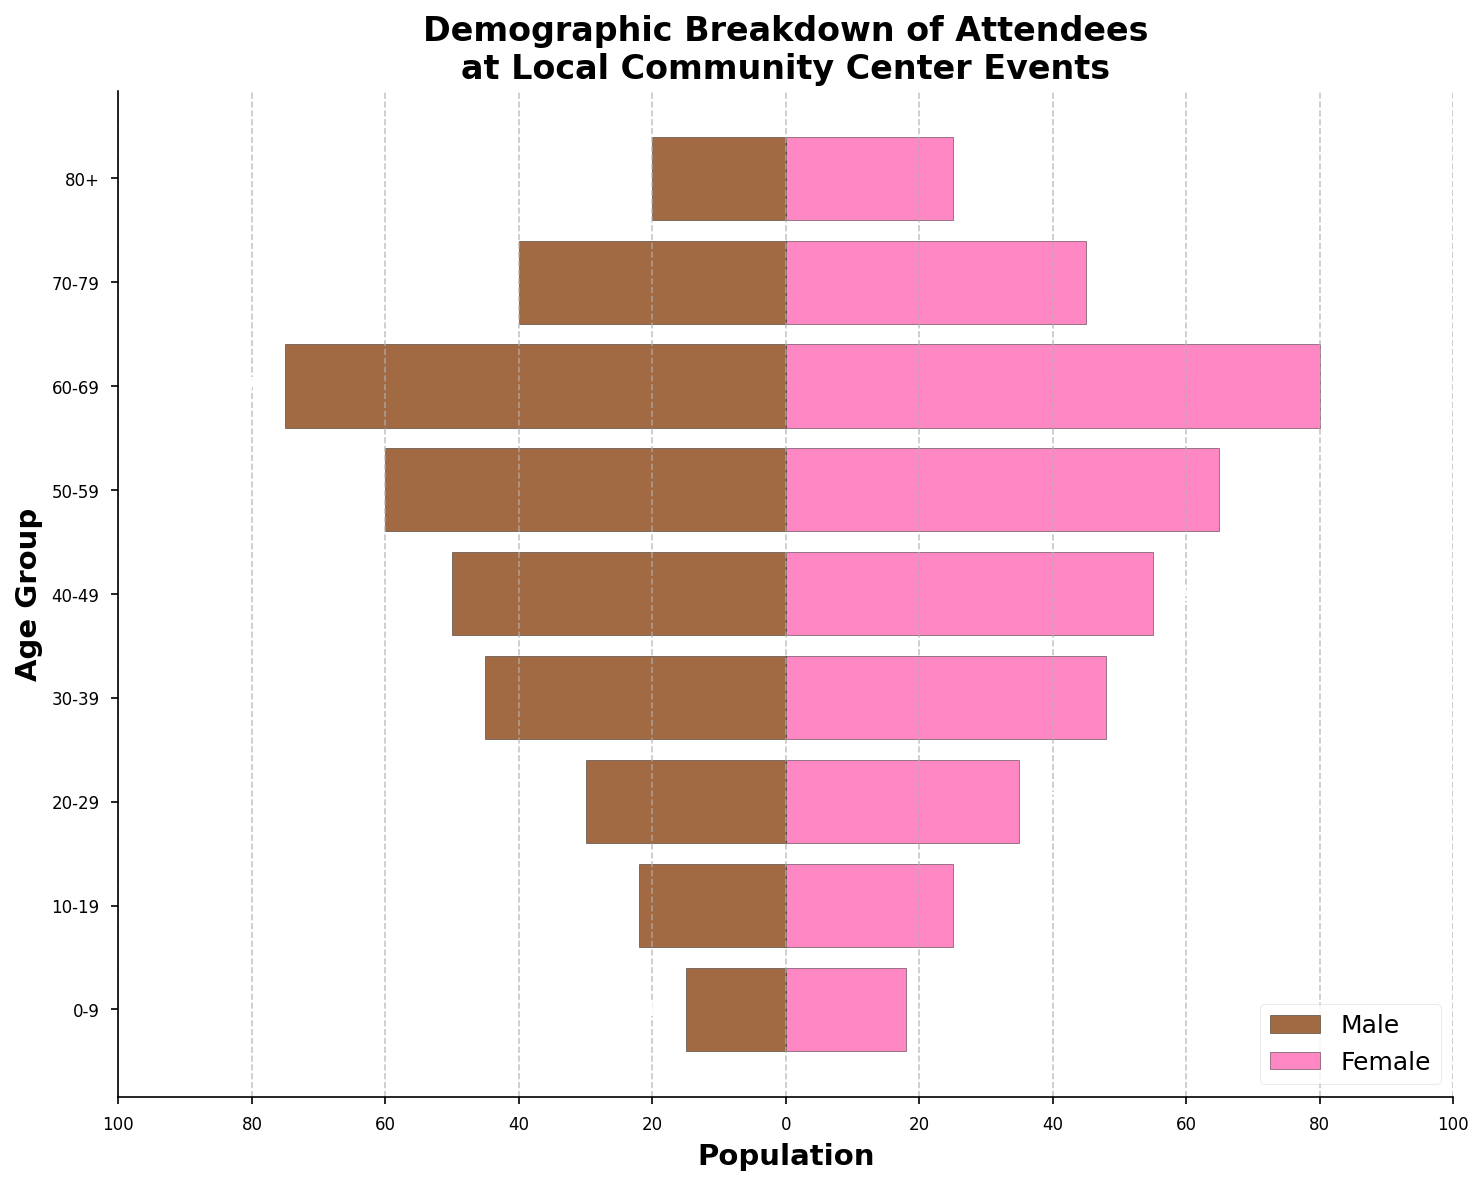Which age group has the highest number of male attendees? The age group with the most male attendees is indicated by the largest bar extending to the left. The 60-69 age group has a bar extending furthest to the left in the male section, indicating the highest number of male attendees.
Answer: 60-69 Which age group has the fewest female attendees? The age group with the fewest female attendees is indicated by the shortest bar extending to the right. The 80+ age group has the shortest bar in the female section, indicating the fewest female attendees.
Answer: 80+ What is the total population of attendees in the 30-39 age group? The total population for the 30-39 age group can be calculated by adding the values for both males and females. For 30-39, there are 45 males and 48 females. So, 45 + 48 = 93.
Answer: 93 How many more female attendees are there than male attendees in the 50-59 age group? To find the difference, subtract the number of male attendees from the number of female attendees. For the 50-59 age group, there are 65 females and 60 males. So, 65 - 60 = 5.
Answer: 5 Which gender has more attendees in the 70-79 age group? By comparing the lengths of the bars for the 70-79 age group, we see that the female bar is longer than the male bar. Hence, there are more female attendees.
Answer: Female In which age group is the total population closest to 100? To find the closest total population to 100, compare the summed values for each age group. The group with the combined count of both genders closest to 100 is the 60-69 group with 75 males and 80 females, totaling 155. However, this isn't close to 100, so the closest is 50-59 with 125.
Answer: 50-59 What percentage of the total attendees are in the 40-49 age group? First, find the total number of attendees across all age groups by summing the male and female values. Next, sum the attendees for the 40-49 group and divide by the total. Finally, multiply by 100 to find the percentage. Total = 15+22+30+45+50+60+75+40+20 + 18+25+35+48+55+65+80+45+25 = 920. For 40-49: 50 (male) + 55 (female) = 105. (105 / 920) * 100 = 11.41%.
Answer: 11.41% Which age group has the most balanced ratio of male to female attendees? The most balanced ratio will be where the lengths of bars for each gender are the most equal. The 0-9 and 70-79 age groups have relatively balanced bars, but the 70-79 group is closer to equal.
Answer: 70-79 What is the combined population for attendees under 30 years old? Sum the values for both males and females in the 0-9, 10-19, and 20-29 age groups. 15+22+30+18+25+35 = 145.
Answer: 145 Which age group shows the largest gender gap in favor of females? The largest gender gap in favor of females can be identified by subtracting male attendees from female attendees for each group and finding the largest positive difference. The 60-69 group has a difference of 80 (female) - 75 (male) = 5, which is large but not the largest. The largest gap is for the 50-59 group: 65 - 60 = 5. Since both values are equal, select either but specify the group to verify.
Answer: 60-69/50-59 with a 5 count difference 